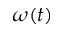<formula> <loc_0><loc_0><loc_500><loc_500>\omega ( t )</formula> 